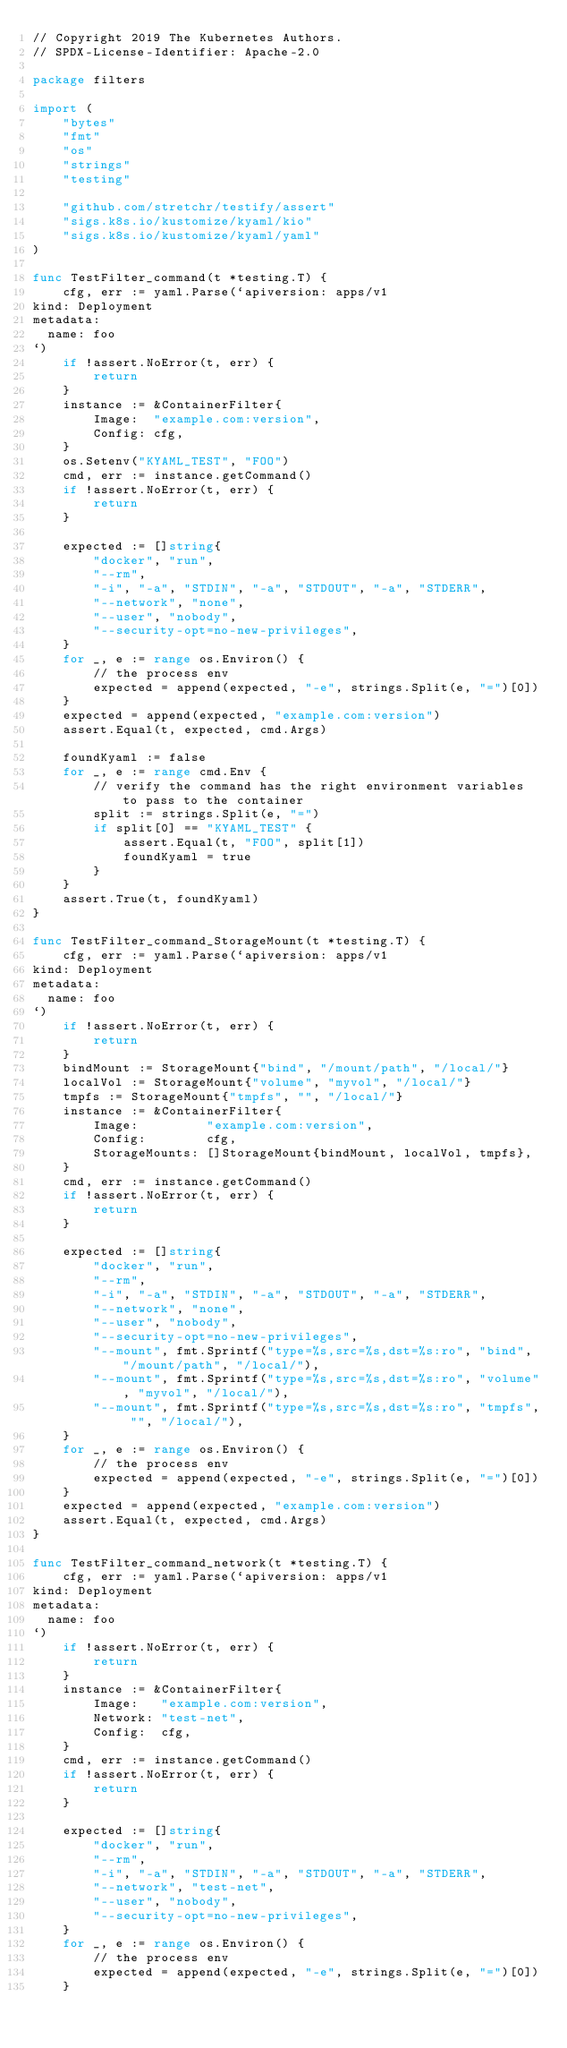Convert code to text. <code><loc_0><loc_0><loc_500><loc_500><_Go_>// Copyright 2019 The Kubernetes Authors.
// SPDX-License-Identifier: Apache-2.0

package filters

import (
	"bytes"
	"fmt"
	"os"
	"strings"
	"testing"

	"github.com/stretchr/testify/assert"
	"sigs.k8s.io/kustomize/kyaml/kio"
	"sigs.k8s.io/kustomize/kyaml/yaml"
)

func TestFilter_command(t *testing.T) {
	cfg, err := yaml.Parse(`apiversion: apps/v1
kind: Deployment
metadata:
  name: foo
`)
	if !assert.NoError(t, err) {
		return
	}
	instance := &ContainerFilter{
		Image:  "example.com:version",
		Config: cfg,
	}
	os.Setenv("KYAML_TEST", "FOO")
	cmd, err := instance.getCommand()
	if !assert.NoError(t, err) {
		return
	}

	expected := []string{
		"docker", "run",
		"--rm",
		"-i", "-a", "STDIN", "-a", "STDOUT", "-a", "STDERR",
		"--network", "none",
		"--user", "nobody",
		"--security-opt=no-new-privileges",
	}
	for _, e := range os.Environ() {
		// the process env
		expected = append(expected, "-e", strings.Split(e, "=")[0])
	}
	expected = append(expected, "example.com:version")
	assert.Equal(t, expected, cmd.Args)

	foundKyaml := false
	for _, e := range cmd.Env {
		// verify the command has the right environment variables to pass to the container
		split := strings.Split(e, "=")
		if split[0] == "KYAML_TEST" {
			assert.Equal(t, "FOO", split[1])
			foundKyaml = true
		}
	}
	assert.True(t, foundKyaml)
}

func TestFilter_command_StorageMount(t *testing.T) {
	cfg, err := yaml.Parse(`apiversion: apps/v1
kind: Deployment
metadata:
  name: foo
`)
	if !assert.NoError(t, err) {
		return
	}
	bindMount := StorageMount{"bind", "/mount/path", "/local/"}
	localVol := StorageMount{"volume", "myvol", "/local/"}
	tmpfs := StorageMount{"tmpfs", "", "/local/"}
	instance := &ContainerFilter{
		Image:         "example.com:version",
		Config:        cfg,
		StorageMounts: []StorageMount{bindMount, localVol, tmpfs},
	}
	cmd, err := instance.getCommand()
	if !assert.NoError(t, err) {
		return
	}

	expected := []string{
		"docker", "run",
		"--rm",
		"-i", "-a", "STDIN", "-a", "STDOUT", "-a", "STDERR",
		"--network", "none",
		"--user", "nobody",
		"--security-opt=no-new-privileges",
		"--mount", fmt.Sprintf("type=%s,src=%s,dst=%s:ro", "bind", "/mount/path", "/local/"),
		"--mount", fmt.Sprintf("type=%s,src=%s,dst=%s:ro", "volume", "myvol", "/local/"),
		"--mount", fmt.Sprintf("type=%s,src=%s,dst=%s:ro", "tmpfs", "", "/local/"),
	}
	for _, e := range os.Environ() {
		// the process env
		expected = append(expected, "-e", strings.Split(e, "=")[0])
	}
	expected = append(expected, "example.com:version")
	assert.Equal(t, expected, cmd.Args)
}

func TestFilter_command_network(t *testing.T) {
	cfg, err := yaml.Parse(`apiversion: apps/v1
kind: Deployment
metadata:
  name: foo
`)
	if !assert.NoError(t, err) {
		return
	}
	instance := &ContainerFilter{
		Image:   "example.com:version",
		Network: "test-net",
		Config:  cfg,
	}
	cmd, err := instance.getCommand()
	if !assert.NoError(t, err) {
		return
	}

	expected := []string{
		"docker", "run",
		"--rm",
		"-i", "-a", "STDIN", "-a", "STDOUT", "-a", "STDERR",
		"--network", "test-net",
		"--user", "nobody",
		"--security-opt=no-new-privileges",
	}
	for _, e := range os.Environ() {
		// the process env
		expected = append(expected, "-e", strings.Split(e, "=")[0])
	}</code> 